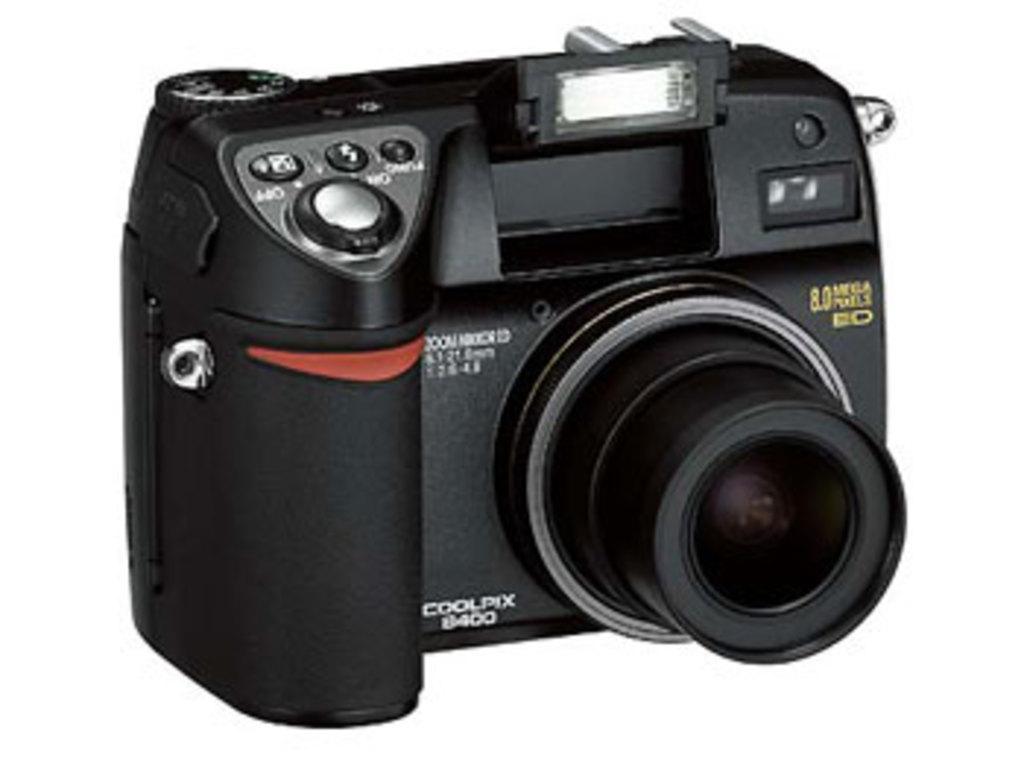Can you describe this image briefly? Here in this picture we can see a black colored camera present over there. 